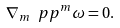<formula> <loc_0><loc_0><loc_500><loc_500>\nabla _ { m } \ p p ^ { m } \omega = 0 .</formula> 